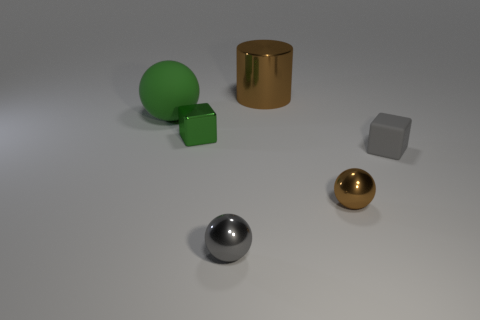Subtract all purple cylinders. Subtract all brown spheres. How many cylinders are left? 1 Add 2 small green metallic blocks. How many objects exist? 8 Subtract all cylinders. How many objects are left? 5 Add 2 matte balls. How many matte balls are left? 3 Add 5 green shiny cubes. How many green shiny cubes exist? 6 Subtract 0 green cylinders. How many objects are left? 6 Subtract all brown things. Subtract all large cyan matte spheres. How many objects are left? 4 